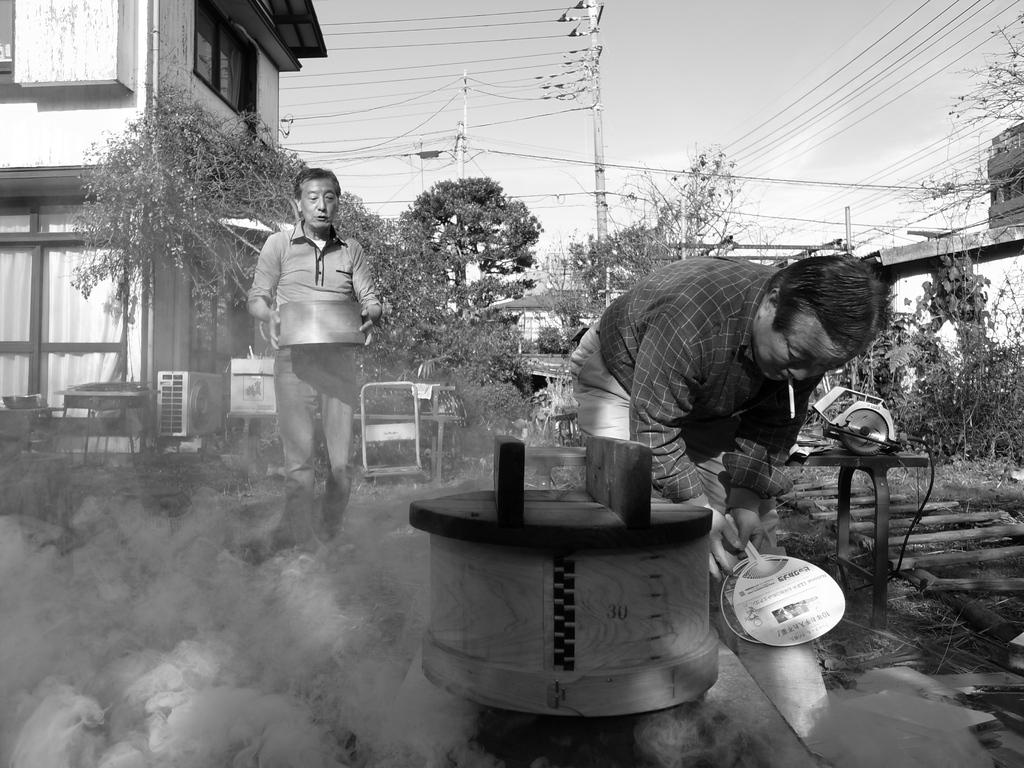How many people are present in the image? There are two men in the image. What is happening with the machine in the image? There is smoke coming from a machine in the image. What can be seen in the background of the image? There are trees, poles, a building, and the sky visible in the background of the image. How many snails can be seen crawling on the clock in the image? There is no clock present in the image, and therefore no snails can be seen crawling on it. 